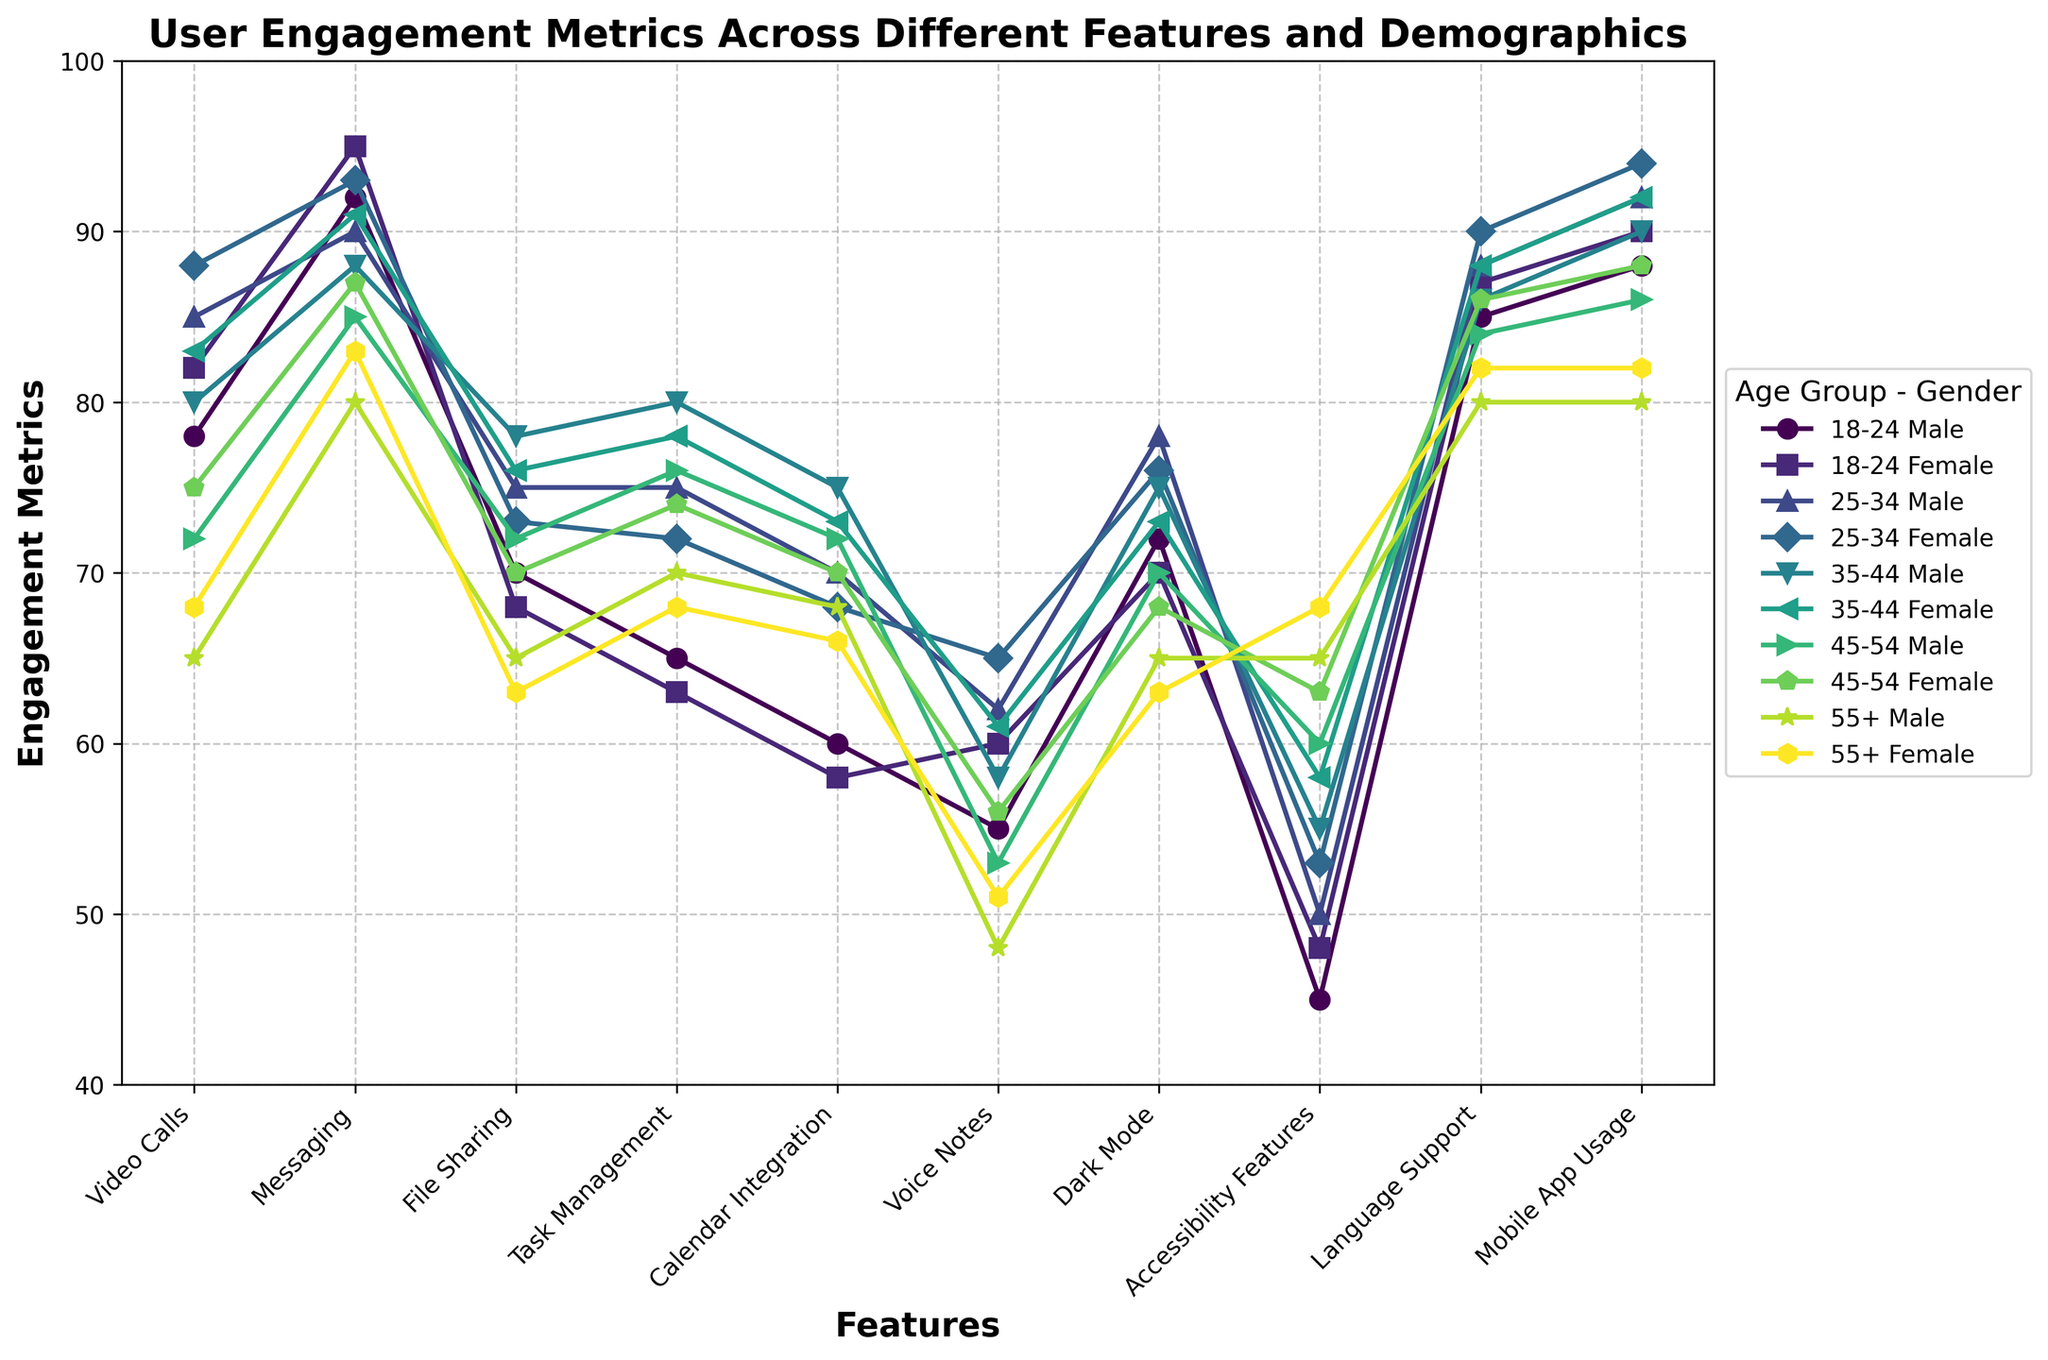What's the most popular feature among 18-24-year-old males? The highest engagement metric for 18-24-year-old males is 92, found in the 'Messaging' feature.
Answer: Messaging Which age group has the highest engagement with the 'Accessibility Features'? For the 'Accessibility Features' row, the highest value is 68, which corresponds to the 55+ Female group.
Answer: 55+ Female What is the average engagement metric for 'Calendar Integration' across all genders and age groups? Summing up the values for 'Calendar Integration': 60 + 58 + 70 + 68 + 75 + 73 + 72 + 70 + 68 + 66 = 680. There are 10 groups, so average = 680 / 10 = 68
Answer: 68 Is the engagement for 'Voice Notes' higher for 18-24 females than for 25-34 males? Comparing the values, 18-24 females have an engagement metric of 60, and 25-34 males have an engagement metric of 62. Since 62 > 60, the engagement is higher for 25-34 males.
Answer: No Which gender shows more engagement with the feature 'Dark Mode', and by how much? Summing the values across all age groups: Males: 72 + 78 + 75 + 70 + 65 = 360; Females: 70 + 76 + 73 + 68 + 63 = 350. Males have 360 - 350 = 10 more engagement points.
Answer: Males by 10 points For the feature 'Video Calls', what is the difference in engagement between the youngest and the oldest male groups? Youngest males (18-24): 78; Oldest males (55+): 65; Difference: 78 - 65 = 13
Answer: 13 Which age group has the lowest engagement metric for the 'File Sharing' feature, and what is that value? The lowest value in the 'File Sharing' feature is 63, which belongs to the 55+ Female group.
Answer: 55+ Female, 63 Comparing the 'Task Management' feature, which segment shows a greater increase in engagement from 18-24 to 25-34: males or females? 18-24 Male: 65, 25-34 Male: 75; Increase for males = 75 - 65 = 10. 18-24 Female: 63, 25-34 Female: 72; Increase for females = 72 - 63 = 9. Males have a greater increase.
Answer: Males What's the median engagement for the feature 'Language Support' across all demographics? The values are 85, 87, 88, 90, 86, 88, 84, 86, 80, 82. Ordering them: 80, 82, 84, 85, 86, 86, 87, 88, 88, 90. The median (average of 5th and 6th values): (86 + 86) / 2 = 86.
Answer: 86 